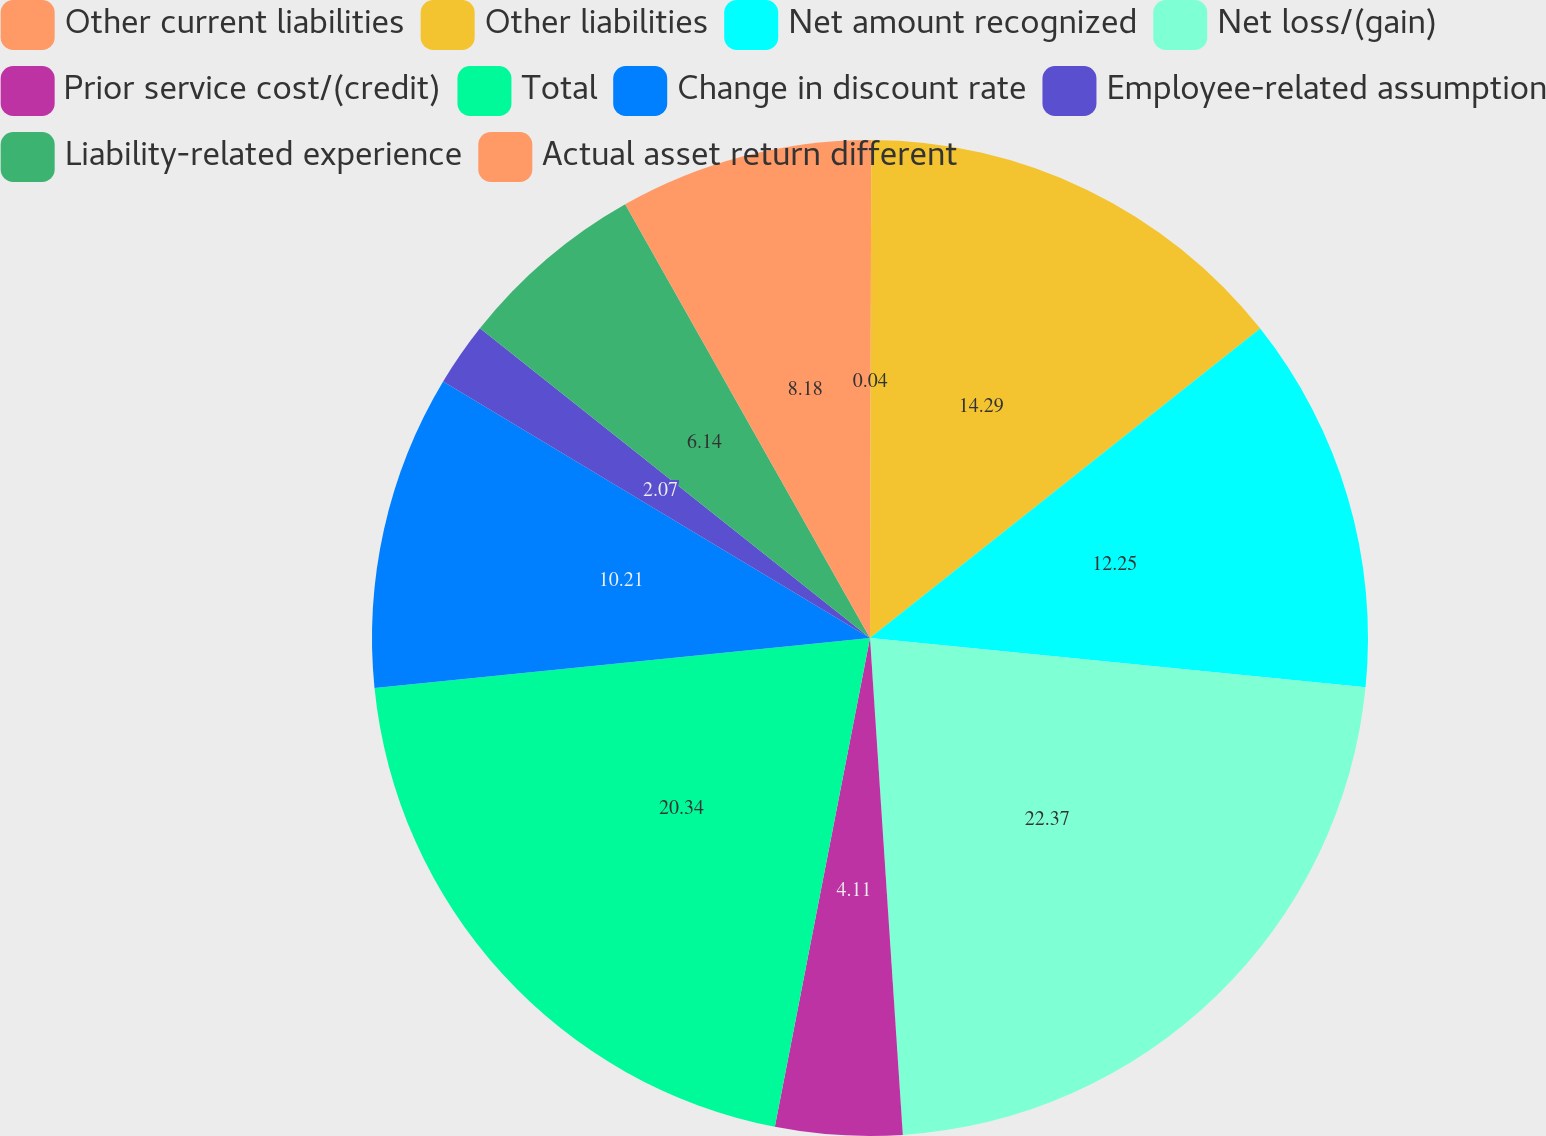Convert chart. <chart><loc_0><loc_0><loc_500><loc_500><pie_chart><fcel>Other current liabilities<fcel>Other liabilities<fcel>Net amount recognized<fcel>Net loss/(gain)<fcel>Prior service cost/(credit)<fcel>Total<fcel>Change in discount rate<fcel>Employee-related assumption<fcel>Liability-related experience<fcel>Actual asset return different<nl><fcel>0.04%<fcel>14.29%<fcel>12.25%<fcel>22.37%<fcel>4.11%<fcel>20.34%<fcel>10.21%<fcel>2.07%<fcel>6.14%<fcel>8.18%<nl></chart> 